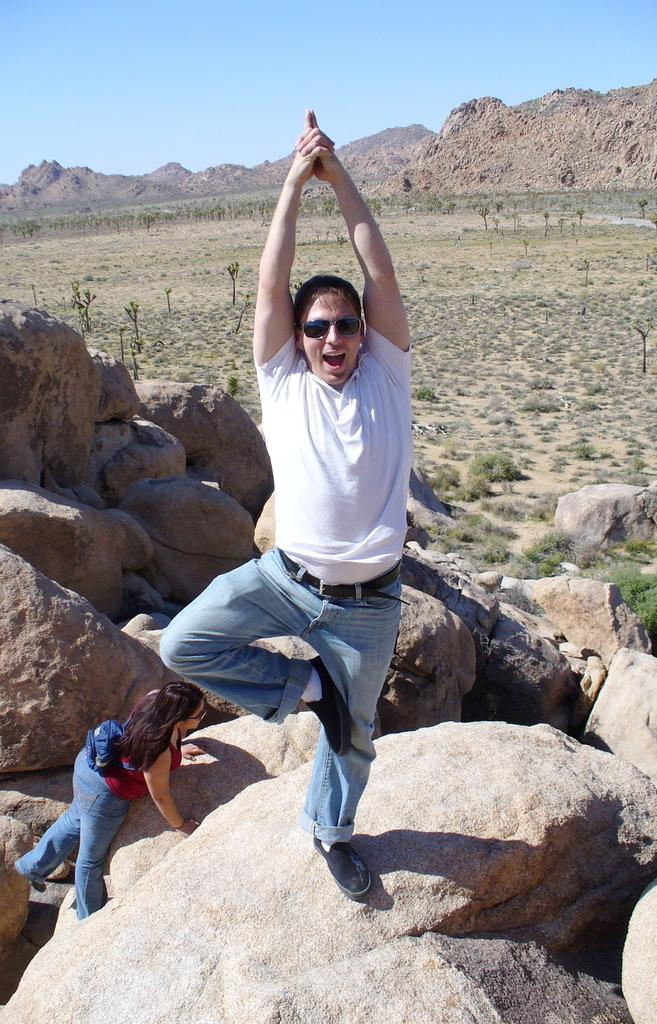What is the man doing in the image? The man is standing on a rock in the image. Who else is present in the image? There is a lady at the bottom of the image. What can be seen in the distance in the image? Hills are visible in the background of the image. What is visible above the hills in the image? The sky is visible in the background of the image. What type of vegetation is present in the image? There are trees in the image. What type of geological formation is present in the image? There are rocks in the image. Who is the manager of the parcel delivery service in the image? There is no mention of a parcel delivery service or a manager in the image. 